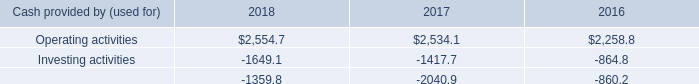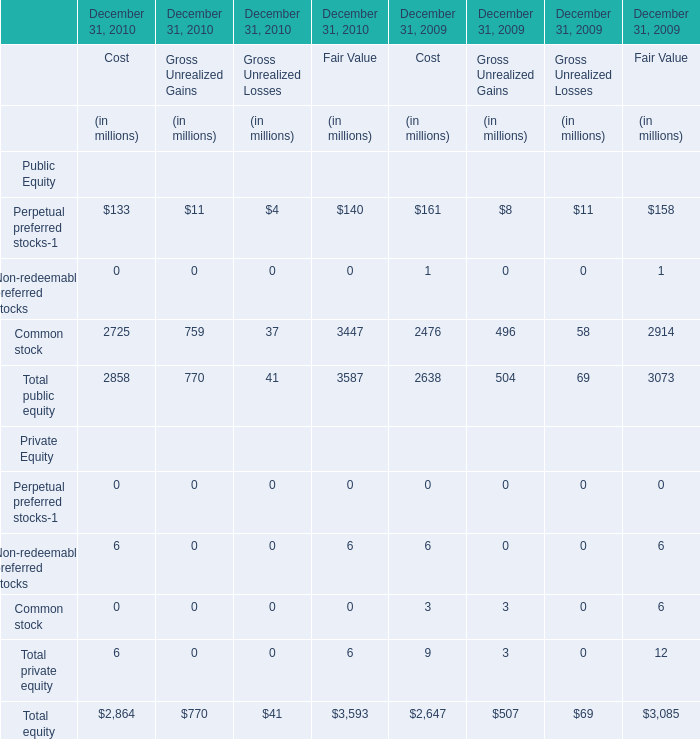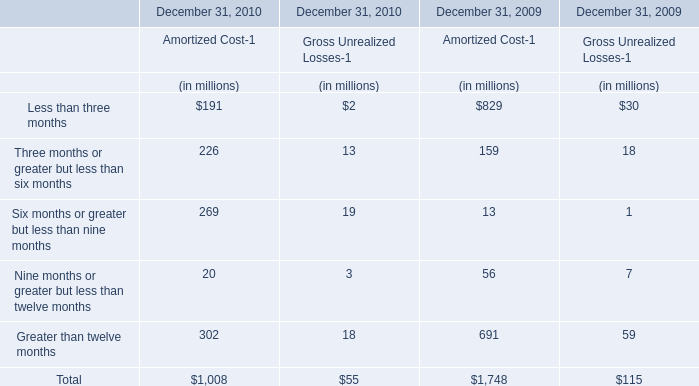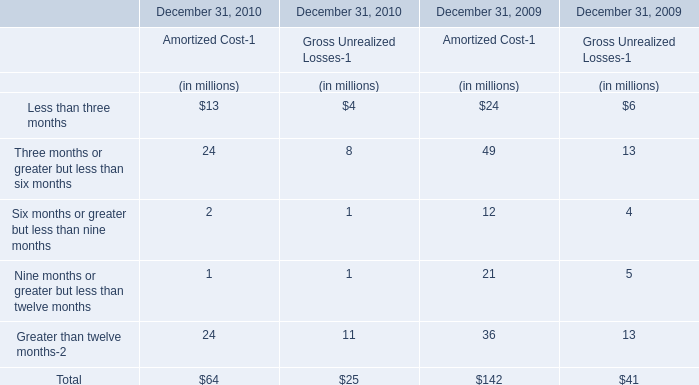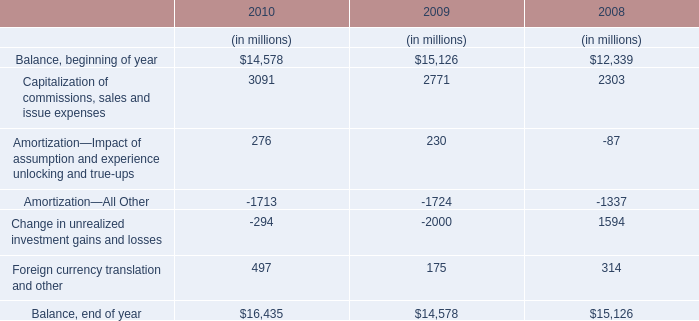What's the greatest value of Amortized Cost-1 in 2010? 
Answer: Greater than twelve months. 